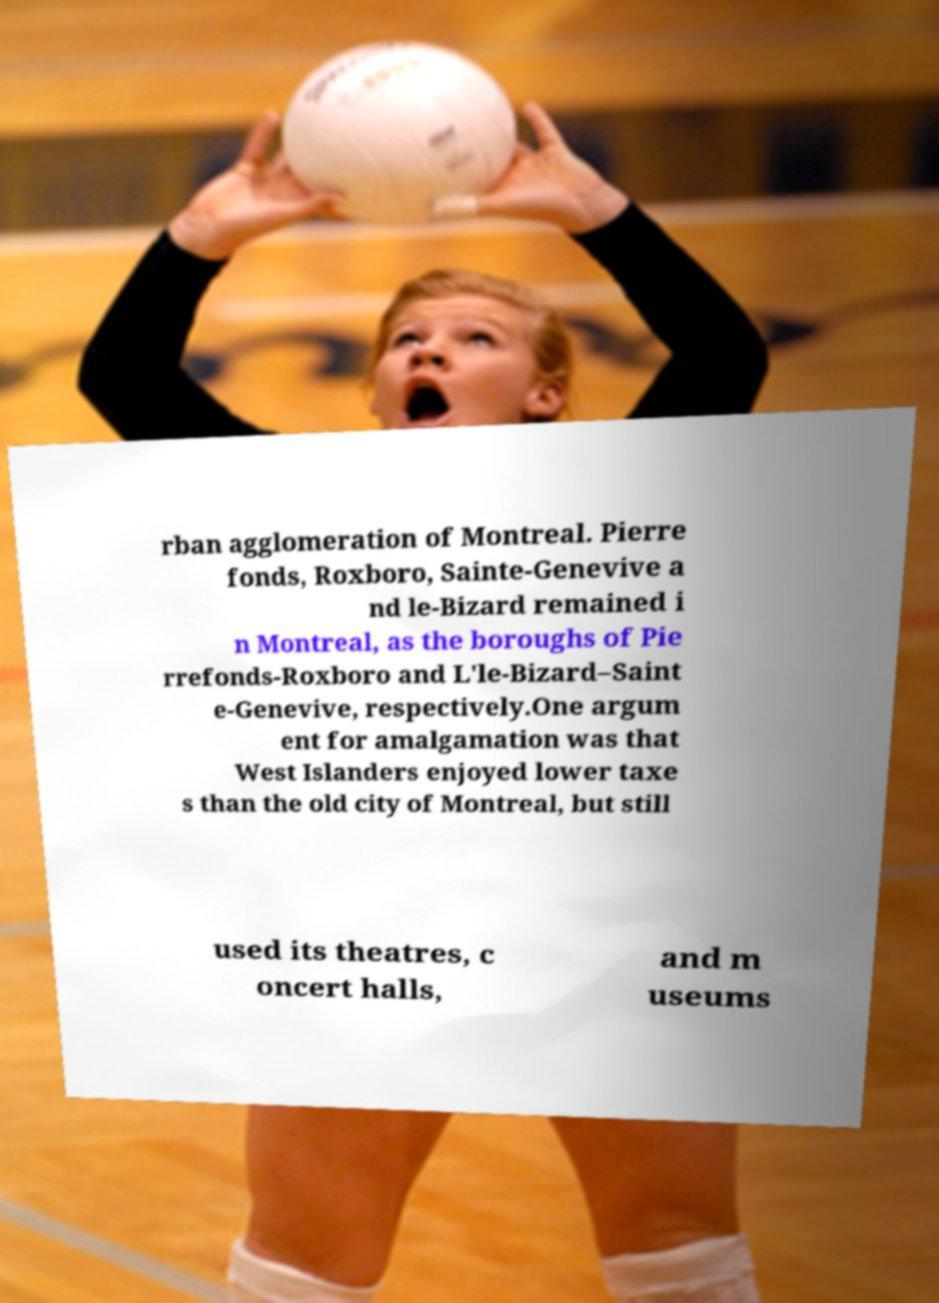What messages or text are displayed in this image? I need them in a readable, typed format. rban agglomeration of Montreal. Pierre fonds, Roxboro, Sainte-Genevive a nd le-Bizard remained i n Montreal, as the boroughs of Pie rrefonds-Roxboro and L'le-Bizard–Saint e-Genevive, respectively.One argum ent for amalgamation was that West Islanders enjoyed lower taxe s than the old city of Montreal, but still used its theatres, c oncert halls, and m useums 